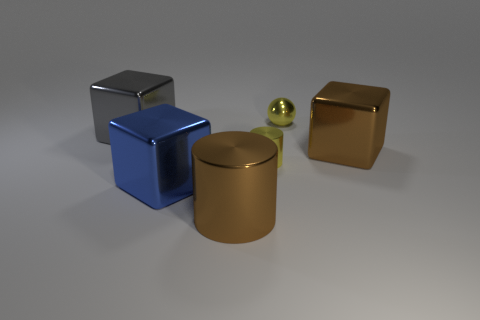There is a big gray thing; is its shape the same as the big brown object on the right side of the brown shiny cylinder?
Your answer should be compact. Yes. Do the tiny metallic ball and the small cylinder have the same color?
Make the answer very short. Yes. There is a object that is behind the blue cube and in front of the brown cube; what size is it?
Give a very brief answer. Small. How many yellow cylinders have the same material as the blue block?
Provide a short and direct response. 1. There is a big cylinder that is made of the same material as the tiny yellow cylinder; what is its color?
Offer a very short reply. Brown. Does the tiny thing that is in front of the metallic ball have the same color as the ball?
Your answer should be very brief. Yes. Are there the same number of big gray things that are in front of the big shiny cylinder and green cylinders?
Your answer should be very brief. Yes. What number of big objects are the same color as the tiny shiny sphere?
Give a very brief answer. 0. Do the brown shiny cylinder and the blue metal object have the same size?
Your response must be concise. Yes. Is the number of big blue shiny cubes that are behind the yellow metallic ball the same as the number of brown cubes that are behind the brown cylinder?
Make the answer very short. No. 